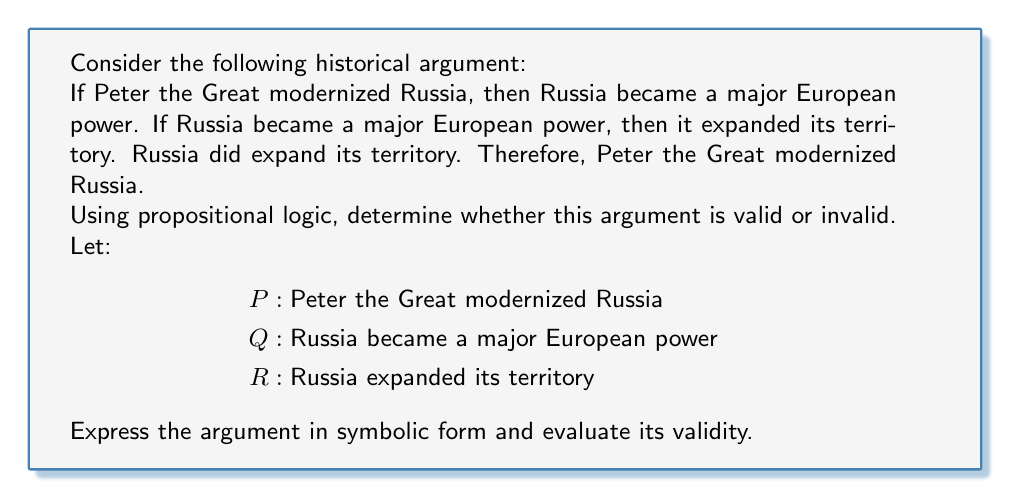Teach me how to tackle this problem. To determine the validity of this argument using propositional logic, we need to follow these steps:

1. Express the argument in symbolic form:

Premises:
1. $P \rightarrow Q$
2. $Q \rightarrow R$
3. $R$

Conclusion: $P$

2. Identify the argument structure:
This argument has the form of affirming the consequent, which is a common logical fallacy.

3. Evaluate the validity:
An argument is valid if and only if it is impossible for the premises to be true and the conclusion false. Let's examine a truth table for this argument:

$$
\begin{array}{|c|c|c|c|c|c|}
\hline
P & Q & R & P \rightarrow Q & Q \rightarrow R & \text{Premises True?} & \text{Conclusion True?} \\
\hline
T & T & T & T & T & T & T \\
T & T & F & T & F & F & T \\
T & F & T & F & T & F & T \\
T & F & F & F & T & F & T \\
F & T & T & T & T & T & F \\
F & T & F & T & F & F & F \\
F & F & T & T & T & T & F \\
F & F & F & T & T & F & F \\
\hline
\end{array}
$$

From the truth table, we can see that there is a row (F T T) where all premises are true, but the conclusion is false. This demonstrates that the argument is invalid.

4. Logical explanation:
The argument commits the fallacy of affirming the consequent. It incorrectly assumes that if the consequent (R) is true, then the antecedent (P) must also be true. However, this is not necessarily the case. Russia could have expanded its territory for reasons other than Peter the Great's modernization efforts.

In propositional logic, we cannot conclude $P$ from $P \rightarrow Q$, $Q \rightarrow R$, and $R$ alone. We would need the additional premise $R \rightarrow P$ to make the argument valid, which is not given and would likely be historically inaccurate.
Answer: The argument is invalid. It commits the fallacy of affirming the consequent, as demonstrated by the truth table where there exists a case (F T T) where all premises are true but the conclusion is false. 